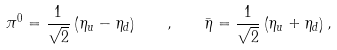<formula> <loc_0><loc_0><loc_500><loc_500>\pi ^ { 0 } = \frac { 1 } { \sqrt { 2 } } \left ( \eta _ { u } - \eta _ { d } \right ) \quad , \quad \bar { \eta } = \frac { 1 } { \sqrt { 2 } } \left ( \eta _ { u } + \eta _ { d } \right ) ,</formula> 